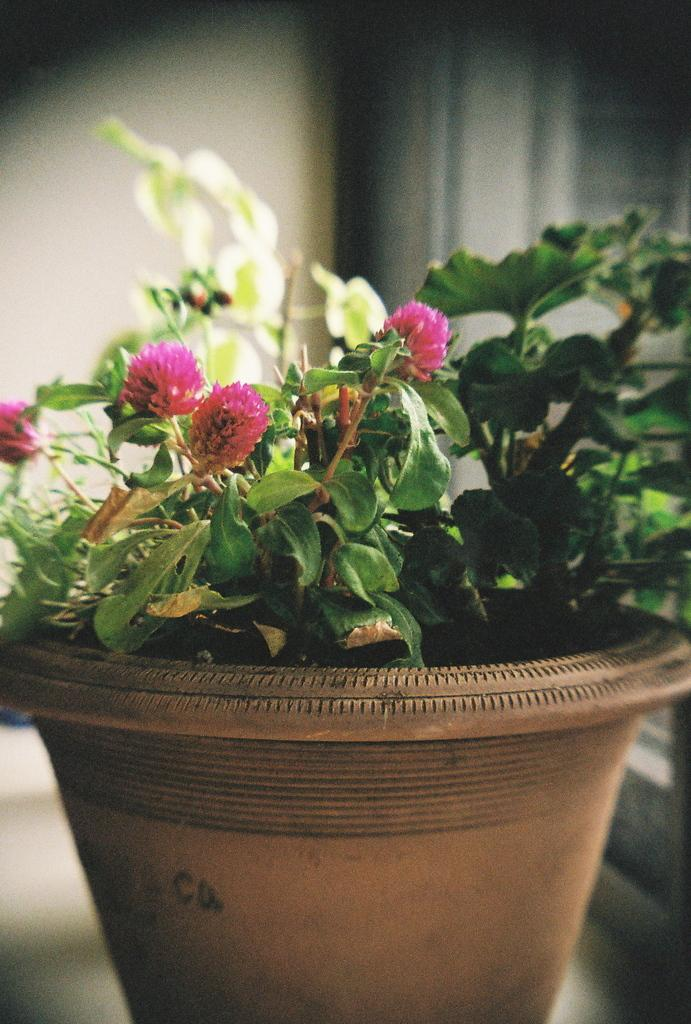What type of plants are visible in the image? There are plants with flowers in the image. How are the plants arranged or contained? The plants are in a pot. Where is the pot located? The pot is on a platform. Can you describe the background of the image? Unfortunately, the background of the image is not clear enough to provide a detailed description. Where are the scissors placed on the shelf in the image? There are no scissors or shelves present in the image. What type of friction is occurring between the plants and the pot in the image? There is no information about friction between the plants and the pot in the image. 